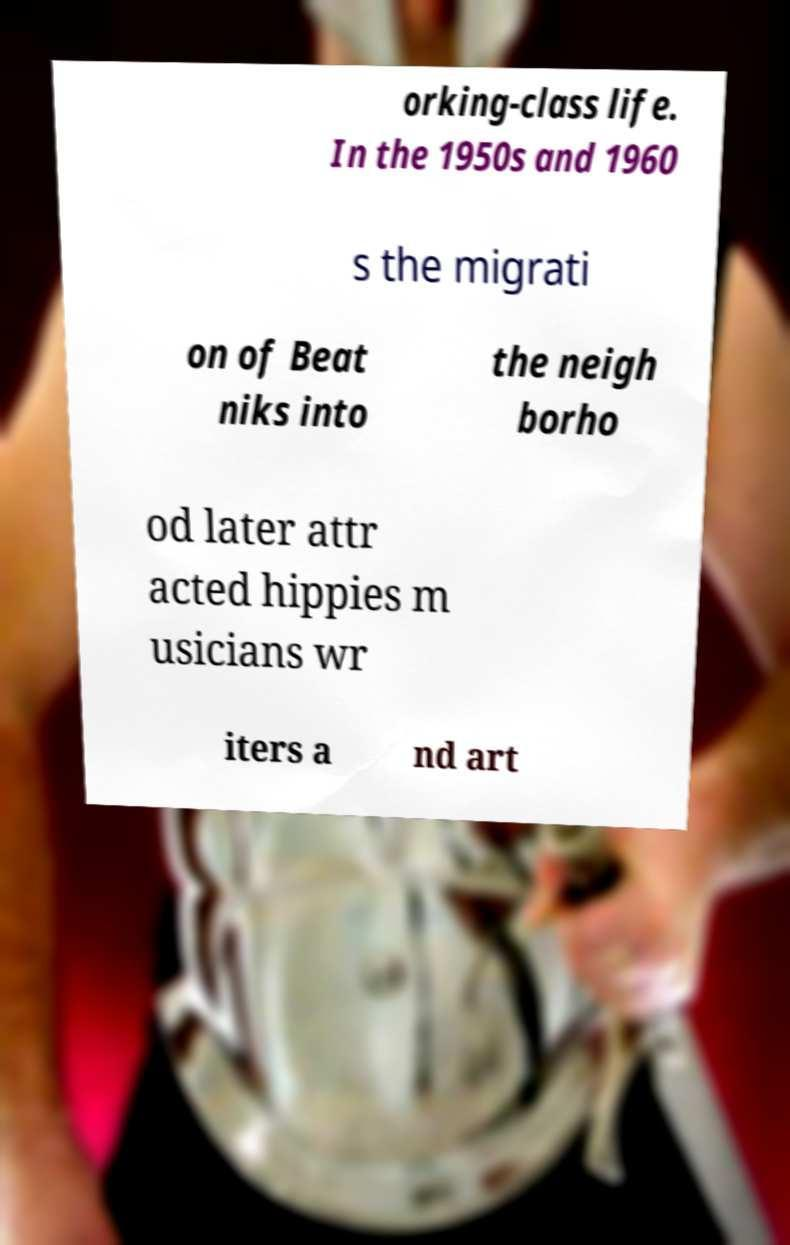There's text embedded in this image that I need extracted. Can you transcribe it verbatim? orking-class life. In the 1950s and 1960 s the migrati on of Beat niks into the neigh borho od later attr acted hippies m usicians wr iters a nd art 